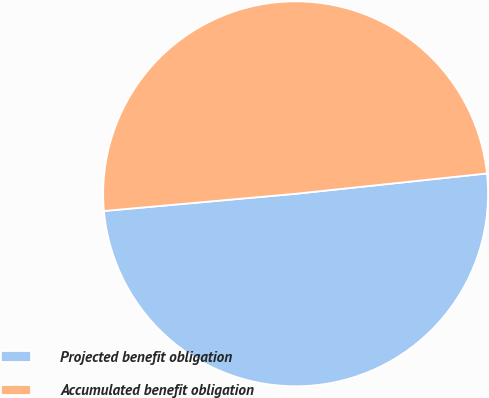<chart> <loc_0><loc_0><loc_500><loc_500><pie_chart><fcel>Projected benefit obligation<fcel>Accumulated benefit obligation<nl><fcel>50.26%<fcel>49.74%<nl></chart> 